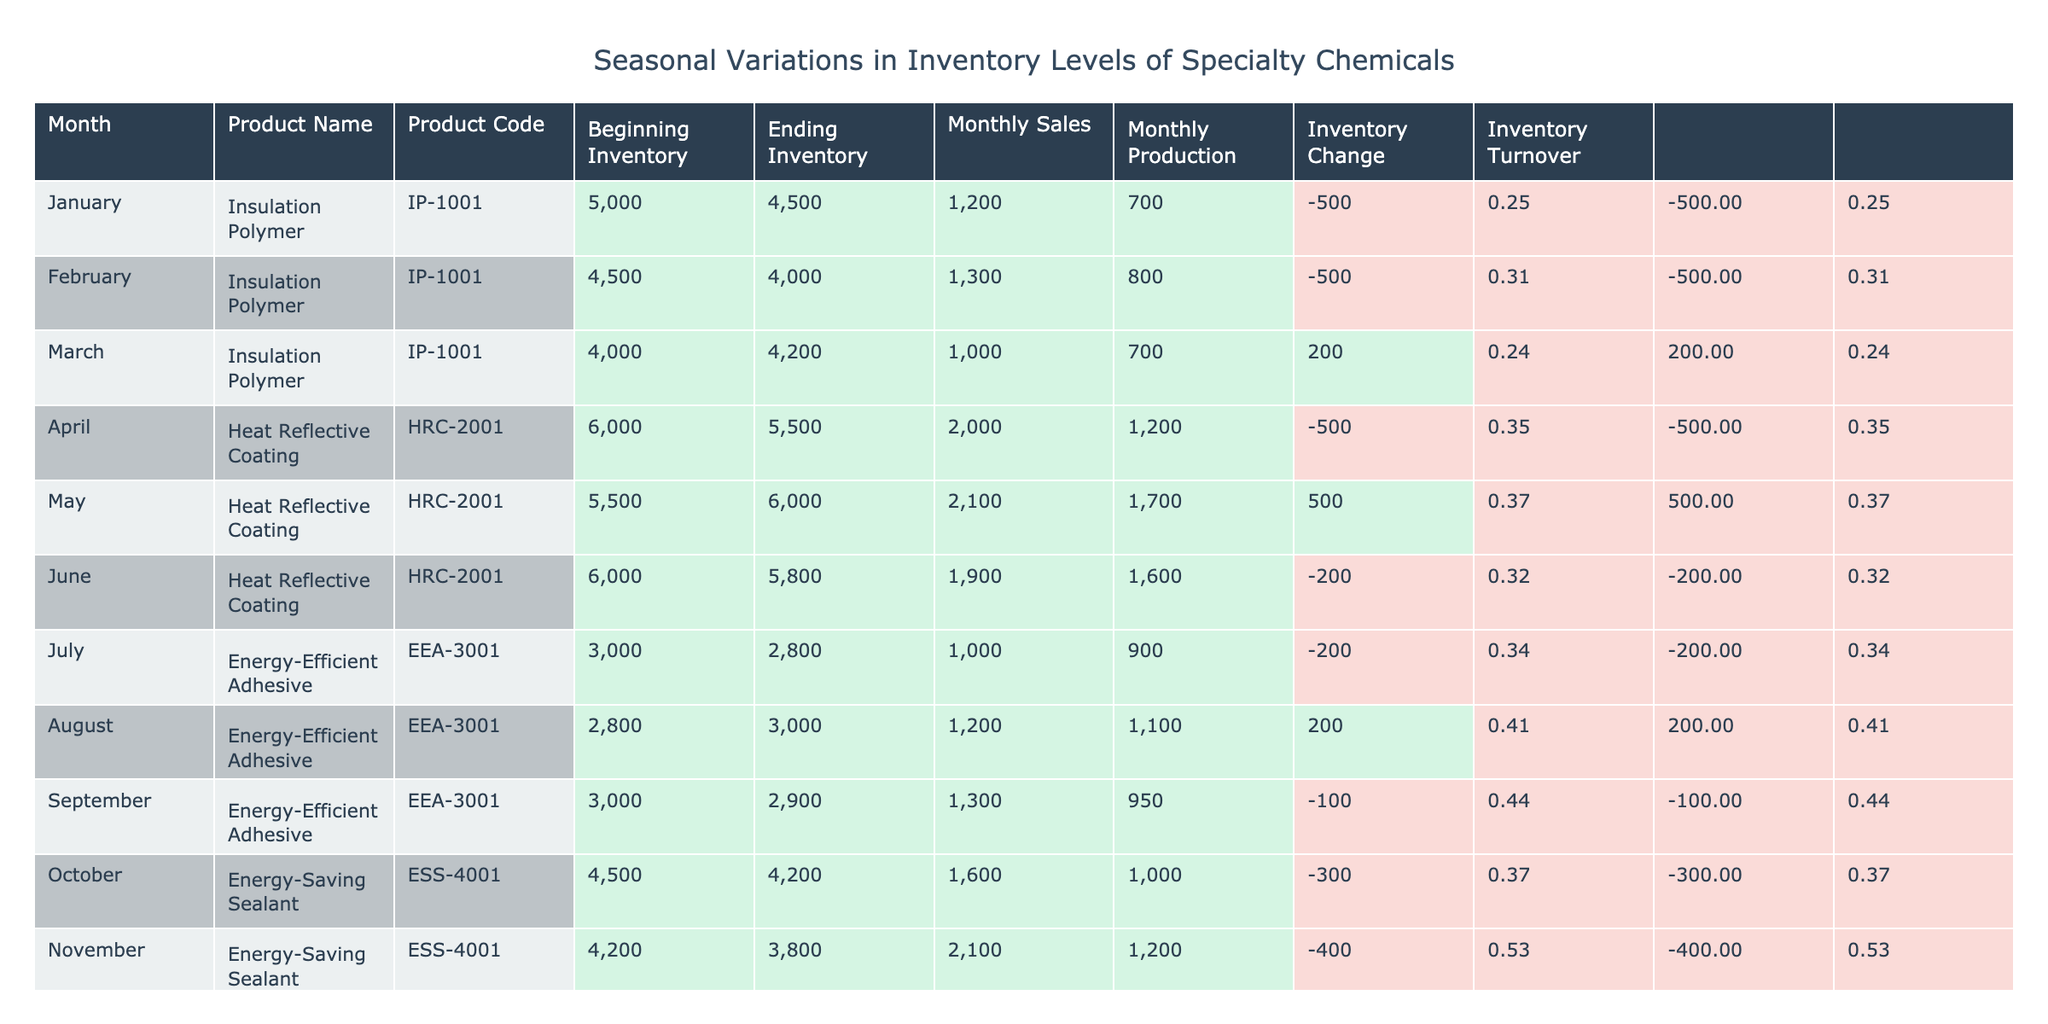What was the product with the highest monthly sales in December? In December, the Energy-Saving Sealant had monthly sales of 2400, which is higher compared to the sales of other products in that month.
Answer: Energy-Saving Sealant What is the ending inventory for Heat Reflective Coating in June? The table shows that the ending inventory for Heat Reflective Coating in June is 5800.
Answer: 5800 How much did the beginning inventory for Insulation Polymer change from January to March? The beginning inventory for Insulation Polymer in January was 5000 and in March it was 4000. The change is 4000 - 5000 = -1000, indicating a decrease.
Answer: -1000 Is the inventory turnover for Energy-Efficient Adhesive in July greater than 1? The monthly sales for Energy-Efficient Adhesive in July is 1000, and the average inventory is (3000 + 2800) / 2 = 2900. The inventory turnover is 1000 / 2900, which is approximately 0.34. Therefore, it is not greater than 1.
Answer: No What is the average monthly sales for the Energy-Saving Sealant over the months it is listed? The monthly sales for Energy-Saving Sealant are 1600 in October, 2100 in November, and 2400 in December. The total is 1600 + 2100 + 2400 = 6100. The average sales is 6100 / 3 = 2033.33.
Answer: 2033.33 What was the inventory change for Heat Reflective Coating from April to June, and was it positive or negative? The ending inventory for Heat Reflective Coating in April is 5500 and in June is 5800. The inventory change is 5800 - 5500 = 300, which is positive.
Answer: Positive Which product had the lowest ending inventory in August? The ending inventory for Energy-Efficient Adhesive in August is 3000, which is lower than other products' ending inventories in that month.
Answer: Energy-Efficient Adhesive What is the difference in monthly production between Energy-Efficient Adhesive in August and September? The monthly production for Energy-Efficient Adhesive in August is 1100 and in September is 950. The difference is 1100 - 950 = 150.
Answer: 150 How many products had an ending inventory of less than 4000 during any month? The products that had ending inventories of less than 4000 were Insulation Polymer in February and Energy-Saving Sealant in December. Thus, there are 2 products that meet this criteria.
Answer: 2 